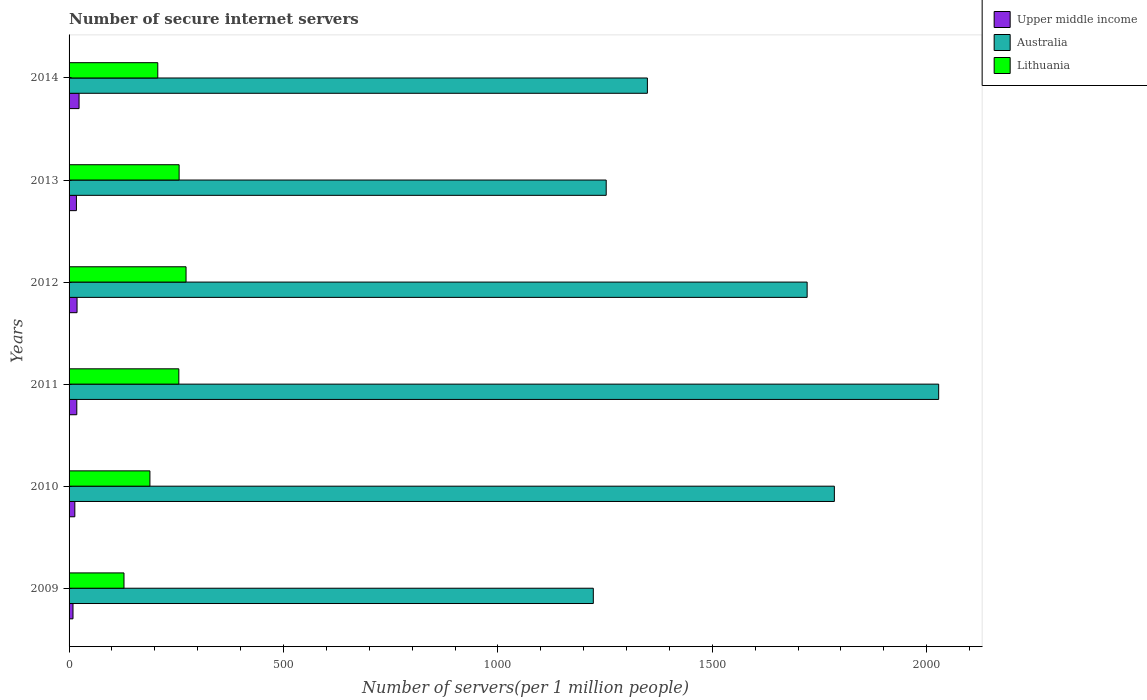How many different coloured bars are there?
Your response must be concise. 3. Are the number of bars per tick equal to the number of legend labels?
Keep it short and to the point. Yes. Are the number of bars on each tick of the Y-axis equal?
Your answer should be compact. Yes. How many bars are there on the 4th tick from the bottom?
Ensure brevity in your answer.  3. What is the number of secure internet servers in Australia in 2011?
Offer a terse response. 2027.8. Across all years, what is the maximum number of secure internet servers in Australia?
Provide a succinct answer. 2027.8. Across all years, what is the minimum number of secure internet servers in Lithuania?
Your response must be concise. 128.05. What is the total number of secure internet servers in Lithuania in the graph?
Make the answer very short. 1308.81. What is the difference between the number of secure internet servers in Lithuania in 2009 and that in 2013?
Your response must be concise. -128.57. What is the difference between the number of secure internet servers in Australia in 2011 and the number of secure internet servers in Lithuania in 2014?
Ensure brevity in your answer.  1820.92. What is the average number of secure internet servers in Upper middle income per year?
Provide a succinct answer. 16.61. In the year 2009, what is the difference between the number of secure internet servers in Upper middle income and number of secure internet servers in Australia?
Give a very brief answer. -1213.29. In how many years, is the number of secure internet servers in Upper middle income greater than 1500 ?
Keep it short and to the point. 0. What is the ratio of the number of secure internet servers in Lithuania in 2010 to that in 2014?
Offer a very short reply. 0.91. Is the number of secure internet servers in Australia in 2009 less than that in 2012?
Keep it short and to the point. Yes. Is the difference between the number of secure internet servers in Upper middle income in 2011 and 2014 greater than the difference between the number of secure internet servers in Australia in 2011 and 2014?
Offer a very short reply. No. What is the difference between the highest and the second highest number of secure internet servers in Lithuania?
Keep it short and to the point. 16.16. What is the difference between the highest and the lowest number of secure internet servers in Australia?
Your response must be concise. 805.35. In how many years, is the number of secure internet servers in Lithuania greater than the average number of secure internet servers in Lithuania taken over all years?
Your answer should be compact. 3. Is the sum of the number of secure internet servers in Upper middle income in 2009 and 2013 greater than the maximum number of secure internet servers in Australia across all years?
Ensure brevity in your answer.  No. What does the 2nd bar from the top in 2013 represents?
Keep it short and to the point. Australia. What does the 3rd bar from the bottom in 2010 represents?
Your answer should be compact. Lithuania. How many bars are there?
Provide a succinct answer. 18. Are the values on the major ticks of X-axis written in scientific E-notation?
Your answer should be very brief. No. Does the graph contain any zero values?
Offer a terse response. No. Does the graph contain grids?
Keep it short and to the point. No. Where does the legend appear in the graph?
Make the answer very short. Top right. How many legend labels are there?
Give a very brief answer. 3. How are the legend labels stacked?
Give a very brief answer. Vertical. What is the title of the graph?
Your answer should be compact. Number of secure internet servers. What is the label or title of the X-axis?
Ensure brevity in your answer.  Number of servers(per 1 million people). What is the Number of servers(per 1 million people) of Upper middle income in 2009?
Make the answer very short. 9.16. What is the Number of servers(per 1 million people) of Australia in 2009?
Give a very brief answer. 1222.45. What is the Number of servers(per 1 million people) of Lithuania in 2009?
Keep it short and to the point. 128.05. What is the Number of servers(per 1 million people) in Upper middle income in 2010?
Keep it short and to the point. 13.42. What is the Number of servers(per 1 million people) in Australia in 2010?
Provide a short and direct response. 1784.56. What is the Number of servers(per 1 million people) of Lithuania in 2010?
Provide a short and direct response. 188.55. What is the Number of servers(per 1 million people) in Upper middle income in 2011?
Keep it short and to the point. 18.02. What is the Number of servers(per 1 million people) in Australia in 2011?
Provide a short and direct response. 2027.8. What is the Number of servers(per 1 million people) of Lithuania in 2011?
Make the answer very short. 255.93. What is the Number of servers(per 1 million people) in Upper middle income in 2012?
Give a very brief answer. 18.6. What is the Number of servers(per 1 million people) of Australia in 2012?
Offer a terse response. 1721.07. What is the Number of servers(per 1 million people) of Lithuania in 2012?
Your response must be concise. 272.78. What is the Number of servers(per 1 million people) in Upper middle income in 2013?
Make the answer very short. 17.16. What is the Number of servers(per 1 million people) in Australia in 2013?
Provide a short and direct response. 1252.54. What is the Number of servers(per 1 million people) in Lithuania in 2013?
Provide a succinct answer. 256.62. What is the Number of servers(per 1 million people) in Upper middle income in 2014?
Make the answer very short. 23.3. What is the Number of servers(per 1 million people) in Australia in 2014?
Make the answer very short. 1348.57. What is the Number of servers(per 1 million people) of Lithuania in 2014?
Provide a succinct answer. 206.87. Across all years, what is the maximum Number of servers(per 1 million people) in Upper middle income?
Your response must be concise. 23.3. Across all years, what is the maximum Number of servers(per 1 million people) in Australia?
Keep it short and to the point. 2027.8. Across all years, what is the maximum Number of servers(per 1 million people) of Lithuania?
Provide a short and direct response. 272.78. Across all years, what is the minimum Number of servers(per 1 million people) of Upper middle income?
Provide a short and direct response. 9.16. Across all years, what is the minimum Number of servers(per 1 million people) in Australia?
Your answer should be compact. 1222.45. Across all years, what is the minimum Number of servers(per 1 million people) of Lithuania?
Provide a short and direct response. 128.05. What is the total Number of servers(per 1 million people) in Upper middle income in the graph?
Provide a succinct answer. 99.66. What is the total Number of servers(per 1 million people) of Australia in the graph?
Your response must be concise. 9356.99. What is the total Number of servers(per 1 million people) of Lithuania in the graph?
Provide a succinct answer. 1308.81. What is the difference between the Number of servers(per 1 million people) of Upper middle income in 2009 and that in 2010?
Offer a very short reply. -4.26. What is the difference between the Number of servers(per 1 million people) of Australia in 2009 and that in 2010?
Ensure brevity in your answer.  -562.11. What is the difference between the Number of servers(per 1 million people) of Lithuania in 2009 and that in 2010?
Make the answer very short. -60.51. What is the difference between the Number of servers(per 1 million people) of Upper middle income in 2009 and that in 2011?
Your response must be concise. -8.86. What is the difference between the Number of servers(per 1 million people) of Australia in 2009 and that in 2011?
Your answer should be compact. -805.35. What is the difference between the Number of servers(per 1 million people) of Lithuania in 2009 and that in 2011?
Provide a succinct answer. -127.89. What is the difference between the Number of servers(per 1 million people) of Upper middle income in 2009 and that in 2012?
Give a very brief answer. -9.43. What is the difference between the Number of servers(per 1 million people) in Australia in 2009 and that in 2012?
Your answer should be very brief. -498.62. What is the difference between the Number of servers(per 1 million people) in Lithuania in 2009 and that in 2012?
Give a very brief answer. -144.73. What is the difference between the Number of servers(per 1 million people) of Upper middle income in 2009 and that in 2013?
Offer a terse response. -7.99. What is the difference between the Number of servers(per 1 million people) of Australia in 2009 and that in 2013?
Give a very brief answer. -30.09. What is the difference between the Number of servers(per 1 million people) of Lithuania in 2009 and that in 2013?
Your answer should be very brief. -128.57. What is the difference between the Number of servers(per 1 million people) of Upper middle income in 2009 and that in 2014?
Your response must be concise. -14.14. What is the difference between the Number of servers(per 1 million people) in Australia in 2009 and that in 2014?
Keep it short and to the point. -126.12. What is the difference between the Number of servers(per 1 million people) of Lithuania in 2009 and that in 2014?
Your answer should be very brief. -78.83. What is the difference between the Number of servers(per 1 million people) of Upper middle income in 2010 and that in 2011?
Keep it short and to the point. -4.6. What is the difference between the Number of servers(per 1 million people) of Australia in 2010 and that in 2011?
Your answer should be very brief. -243.23. What is the difference between the Number of servers(per 1 million people) in Lithuania in 2010 and that in 2011?
Provide a succinct answer. -67.38. What is the difference between the Number of servers(per 1 million people) in Upper middle income in 2010 and that in 2012?
Provide a succinct answer. -5.17. What is the difference between the Number of servers(per 1 million people) of Australia in 2010 and that in 2012?
Your answer should be compact. 63.49. What is the difference between the Number of servers(per 1 million people) of Lithuania in 2010 and that in 2012?
Provide a succinct answer. -84.23. What is the difference between the Number of servers(per 1 million people) in Upper middle income in 2010 and that in 2013?
Offer a terse response. -3.73. What is the difference between the Number of servers(per 1 million people) of Australia in 2010 and that in 2013?
Offer a terse response. 532.02. What is the difference between the Number of servers(per 1 million people) of Lithuania in 2010 and that in 2013?
Offer a terse response. -68.07. What is the difference between the Number of servers(per 1 million people) of Upper middle income in 2010 and that in 2014?
Your answer should be compact. -9.88. What is the difference between the Number of servers(per 1 million people) in Australia in 2010 and that in 2014?
Make the answer very short. 435.99. What is the difference between the Number of servers(per 1 million people) of Lithuania in 2010 and that in 2014?
Offer a terse response. -18.32. What is the difference between the Number of servers(per 1 million people) in Upper middle income in 2011 and that in 2012?
Make the answer very short. -0.58. What is the difference between the Number of servers(per 1 million people) of Australia in 2011 and that in 2012?
Make the answer very short. 306.72. What is the difference between the Number of servers(per 1 million people) of Lithuania in 2011 and that in 2012?
Provide a short and direct response. -16.84. What is the difference between the Number of servers(per 1 million people) of Upper middle income in 2011 and that in 2013?
Your answer should be compact. 0.86. What is the difference between the Number of servers(per 1 million people) of Australia in 2011 and that in 2013?
Your response must be concise. 775.26. What is the difference between the Number of servers(per 1 million people) in Lithuania in 2011 and that in 2013?
Provide a short and direct response. -0.68. What is the difference between the Number of servers(per 1 million people) in Upper middle income in 2011 and that in 2014?
Ensure brevity in your answer.  -5.28. What is the difference between the Number of servers(per 1 million people) in Australia in 2011 and that in 2014?
Provide a short and direct response. 679.22. What is the difference between the Number of servers(per 1 million people) of Lithuania in 2011 and that in 2014?
Offer a very short reply. 49.06. What is the difference between the Number of servers(per 1 million people) of Upper middle income in 2012 and that in 2013?
Ensure brevity in your answer.  1.44. What is the difference between the Number of servers(per 1 million people) of Australia in 2012 and that in 2013?
Keep it short and to the point. 468.54. What is the difference between the Number of servers(per 1 million people) of Lithuania in 2012 and that in 2013?
Your answer should be very brief. 16.16. What is the difference between the Number of servers(per 1 million people) of Upper middle income in 2012 and that in 2014?
Provide a succinct answer. -4.7. What is the difference between the Number of servers(per 1 million people) in Australia in 2012 and that in 2014?
Make the answer very short. 372.5. What is the difference between the Number of servers(per 1 million people) in Lithuania in 2012 and that in 2014?
Offer a very short reply. 65.9. What is the difference between the Number of servers(per 1 million people) in Upper middle income in 2013 and that in 2014?
Ensure brevity in your answer.  -6.14. What is the difference between the Number of servers(per 1 million people) of Australia in 2013 and that in 2014?
Give a very brief answer. -96.04. What is the difference between the Number of servers(per 1 million people) of Lithuania in 2013 and that in 2014?
Ensure brevity in your answer.  49.75. What is the difference between the Number of servers(per 1 million people) in Upper middle income in 2009 and the Number of servers(per 1 million people) in Australia in 2010?
Offer a very short reply. -1775.4. What is the difference between the Number of servers(per 1 million people) of Upper middle income in 2009 and the Number of servers(per 1 million people) of Lithuania in 2010?
Your response must be concise. -179.39. What is the difference between the Number of servers(per 1 million people) of Australia in 2009 and the Number of servers(per 1 million people) of Lithuania in 2010?
Your answer should be compact. 1033.9. What is the difference between the Number of servers(per 1 million people) in Upper middle income in 2009 and the Number of servers(per 1 million people) in Australia in 2011?
Offer a very short reply. -2018.63. What is the difference between the Number of servers(per 1 million people) of Upper middle income in 2009 and the Number of servers(per 1 million people) of Lithuania in 2011?
Keep it short and to the point. -246.77. What is the difference between the Number of servers(per 1 million people) in Australia in 2009 and the Number of servers(per 1 million people) in Lithuania in 2011?
Make the answer very short. 966.51. What is the difference between the Number of servers(per 1 million people) in Upper middle income in 2009 and the Number of servers(per 1 million people) in Australia in 2012?
Make the answer very short. -1711.91. What is the difference between the Number of servers(per 1 million people) of Upper middle income in 2009 and the Number of servers(per 1 million people) of Lithuania in 2012?
Give a very brief answer. -263.62. What is the difference between the Number of servers(per 1 million people) of Australia in 2009 and the Number of servers(per 1 million people) of Lithuania in 2012?
Your response must be concise. 949.67. What is the difference between the Number of servers(per 1 million people) in Upper middle income in 2009 and the Number of servers(per 1 million people) in Australia in 2013?
Ensure brevity in your answer.  -1243.37. What is the difference between the Number of servers(per 1 million people) of Upper middle income in 2009 and the Number of servers(per 1 million people) of Lithuania in 2013?
Make the answer very short. -247.46. What is the difference between the Number of servers(per 1 million people) of Australia in 2009 and the Number of servers(per 1 million people) of Lithuania in 2013?
Make the answer very short. 965.83. What is the difference between the Number of servers(per 1 million people) of Upper middle income in 2009 and the Number of servers(per 1 million people) of Australia in 2014?
Provide a short and direct response. -1339.41. What is the difference between the Number of servers(per 1 million people) of Upper middle income in 2009 and the Number of servers(per 1 million people) of Lithuania in 2014?
Offer a very short reply. -197.71. What is the difference between the Number of servers(per 1 million people) in Australia in 2009 and the Number of servers(per 1 million people) in Lithuania in 2014?
Provide a short and direct response. 1015.58. What is the difference between the Number of servers(per 1 million people) of Upper middle income in 2010 and the Number of servers(per 1 million people) of Australia in 2011?
Offer a terse response. -2014.37. What is the difference between the Number of servers(per 1 million people) in Upper middle income in 2010 and the Number of servers(per 1 million people) in Lithuania in 2011?
Ensure brevity in your answer.  -242.51. What is the difference between the Number of servers(per 1 million people) of Australia in 2010 and the Number of servers(per 1 million people) of Lithuania in 2011?
Keep it short and to the point. 1528.63. What is the difference between the Number of servers(per 1 million people) in Upper middle income in 2010 and the Number of servers(per 1 million people) in Australia in 2012?
Your response must be concise. -1707.65. What is the difference between the Number of servers(per 1 million people) in Upper middle income in 2010 and the Number of servers(per 1 million people) in Lithuania in 2012?
Your answer should be very brief. -259.35. What is the difference between the Number of servers(per 1 million people) of Australia in 2010 and the Number of servers(per 1 million people) of Lithuania in 2012?
Your response must be concise. 1511.78. What is the difference between the Number of servers(per 1 million people) of Upper middle income in 2010 and the Number of servers(per 1 million people) of Australia in 2013?
Keep it short and to the point. -1239.11. What is the difference between the Number of servers(per 1 million people) in Upper middle income in 2010 and the Number of servers(per 1 million people) in Lithuania in 2013?
Provide a succinct answer. -243.2. What is the difference between the Number of servers(per 1 million people) of Australia in 2010 and the Number of servers(per 1 million people) of Lithuania in 2013?
Provide a short and direct response. 1527.94. What is the difference between the Number of servers(per 1 million people) in Upper middle income in 2010 and the Number of servers(per 1 million people) in Australia in 2014?
Provide a succinct answer. -1335.15. What is the difference between the Number of servers(per 1 million people) of Upper middle income in 2010 and the Number of servers(per 1 million people) of Lithuania in 2014?
Give a very brief answer. -193.45. What is the difference between the Number of servers(per 1 million people) of Australia in 2010 and the Number of servers(per 1 million people) of Lithuania in 2014?
Provide a succinct answer. 1577.69. What is the difference between the Number of servers(per 1 million people) of Upper middle income in 2011 and the Number of servers(per 1 million people) of Australia in 2012?
Your response must be concise. -1703.05. What is the difference between the Number of servers(per 1 million people) in Upper middle income in 2011 and the Number of servers(per 1 million people) in Lithuania in 2012?
Your answer should be very brief. -254.76. What is the difference between the Number of servers(per 1 million people) in Australia in 2011 and the Number of servers(per 1 million people) in Lithuania in 2012?
Your answer should be compact. 1755.02. What is the difference between the Number of servers(per 1 million people) in Upper middle income in 2011 and the Number of servers(per 1 million people) in Australia in 2013?
Your answer should be very brief. -1234.52. What is the difference between the Number of servers(per 1 million people) in Upper middle income in 2011 and the Number of servers(per 1 million people) in Lithuania in 2013?
Keep it short and to the point. -238.6. What is the difference between the Number of servers(per 1 million people) of Australia in 2011 and the Number of servers(per 1 million people) of Lithuania in 2013?
Your answer should be very brief. 1771.18. What is the difference between the Number of servers(per 1 million people) of Upper middle income in 2011 and the Number of servers(per 1 million people) of Australia in 2014?
Keep it short and to the point. -1330.55. What is the difference between the Number of servers(per 1 million people) of Upper middle income in 2011 and the Number of servers(per 1 million people) of Lithuania in 2014?
Provide a succinct answer. -188.85. What is the difference between the Number of servers(per 1 million people) of Australia in 2011 and the Number of servers(per 1 million people) of Lithuania in 2014?
Offer a terse response. 1820.92. What is the difference between the Number of servers(per 1 million people) of Upper middle income in 2012 and the Number of servers(per 1 million people) of Australia in 2013?
Offer a terse response. -1233.94. What is the difference between the Number of servers(per 1 million people) in Upper middle income in 2012 and the Number of servers(per 1 million people) in Lithuania in 2013?
Your response must be concise. -238.02. What is the difference between the Number of servers(per 1 million people) in Australia in 2012 and the Number of servers(per 1 million people) in Lithuania in 2013?
Give a very brief answer. 1464.45. What is the difference between the Number of servers(per 1 million people) of Upper middle income in 2012 and the Number of servers(per 1 million people) of Australia in 2014?
Provide a short and direct response. -1329.98. What is the difference between the Number of servers(per 1 million people) of Upper middle income in 2012 and the Number of servers(per 1 million people) of Lithuania in 2014?
Your response must be concise. -188.28. What is the difference between the Number of servers(per 1 million people) of Australia in 2012 and the Number of servers(per 1 million people) of Lithuania in 2014?
Make the answer very short. 1514.2. What is the difference between the Number of servers(per 1 million people) in Upper middle income in 2013 and the Number of servers(per 1 million people) in Australia in 2014?
Your answer should be very brief. -1331.42. What is the difference between the Number of servers(per 1 million people) in Upper middle income in 2013 and the Number of servers(per 1 million people) in Lithuania in 2014?
Provide a short and direct response. -189.72. What is the difference between the Number of servers(per 1 million people) in Australia in 2013 and the Number of servers(per 1 million people) in Lithuania in 2014?
Your response must be concise. 1045.66. What is the average Number of servers(per 1 million people) in Upper middle income per year?
Keep it short and to the point. 16.61. What is the average Number of servers(per 1 million people) in Australia per year?
Provide a succinct answer. 1559.5. What is the average Number of servers(per 1 million people) in Lithuania per year?
Give a very brief answer. 218.13. In the year 2009, what is the difference between the Number of servers(per 1 million people) in Upper middle income and Number of servers(per 1 million people) in Australia?
Make the answer very short. -1213.29. In the year 2009, what is the difference between the Number of servers(per 1 million people) in Upper middle income and Number of servers(per 1 million people) in Lithuania?
Make the answer very short. -118.88. In the year 2009, what is the difference between the Number of servers(per 1 million people) in Australia and Number of servers(per 1 million people) in Lithuania?
Keep it short and to the point. 1094.4. In the year 2010, what is the difference between the Number of servers(per 1 million people) in Upper middle income and Number of servers(per 1 million people) in Australia?
Ensure brevity in your answer.  -1771.14. In the year 2010, what is the difference between the Number of servers(per 1 million people) of Upper middle income and Number of servers(per 1 million people) of Lithuania?
Give a very brief answer. -175.13. In the year 2010, what is the difference between the Number of servers(per 1 million people) in Australia and Number of servers(per 1 million people) in Lithuania?
Ensure brevity in your answer.  1596.01. In the year 2011, what is the difference between the Number of servers(per 1 million people) in Upper middle income and Number of servers(per 1 million people) in Australia?
Provide a short and direct response. -2009.77. In the year 2011, what is the difference between the Number of servers(per 1 million people) in Upper middle income and Number of servers(per 1 million people) in Lithuania?
Provide a short and direct response. -237.91. In the year 2011, what is the difference between the Number of servers(per 1 million people) of Australia and Number of servers(per 1 million people) of Lithuania?
Offer a very short reply. 1771.86. In the year 2012, what is the difference between the Number of servers(per 1 million people) of Upper middle income and Number of servers(per 1 million people) of Australia?
Offer a very short reply. -1702.48. In the year 2012, what is the difference between the Number of servers(per 1 million people) in Upper middle income and Number of servers(per 1 million people) in Lithuania?
Keep it short and to the point. -254.18. In the year 2012, what is the difference between the Number of servers(per 1 million people) of Australia and Number of servers(per 1 million people) of Lithuania?
Provide a short and direct response. 1448.3. In the year 2013, what is the difference between the Number of servers(per 1 million people) of Upper middle income and Number of servers(per 1 million people) of Australia?
Keep it short and to the point. -1235.38. In the year 2013, what is the difference between the Number of servers(per 1 million people) of Upper middle income and Number of servers(per 1 million people) of Lithuania?
Ensure brevity in your answer.  -239.46. In the year 2013, what is the difference between the Number of servers(per 1 million people) in Australia and Number of servers(per 1 million people) in Lithuania?
Keep it short and to the point. 995.92. In the year 2014, what is the difference between the Number of servers(per 1 million people) of Upper middle income and Number of servers(per 1 million people) of Australia?
Your response must be concise. -1325.27. In the year 2014, what is the difference between the Number of servers(per 1 million people) in Upper middle income and Number of servers(per 1 million people) in Lithuania?
Your answer should be very brief. -183.57. In the year 2014, what is the difference between the Number of servers(per 1 million people) in Australia and Number of servers(per 1 million people) in Lithuania?
Give a very brief answer. 1141.7. What is the ratio of the Number of servers(per 1 million people) in Upper middle income in 2009 to that in 2010?
Provide a succinct answer. 0.68. What is the ratio of the Number of servers(per 1 million people) in Australia in 2009 to that in 2010?
Give a very brief answer. 0.69. What is the ratio of the Number of servers(per 1 million people) of Lithuania in 2009 to that in 2010?
Offer a terse response. 0.68. What is the ratio of the Number of servers(per 1 million people) in Upper middle income in 2009 to that in 2011?
Your answer should be compact. 0.51. What is the ratio of the Number of servers(per 1 million people) of Australia in 2009 to that in 2011?
Give a very brief answer. 0.6. What is the ratio of the Number of servers(per 1 million people) of Lithuania in 2009 to that in 2011?
Provide a succinct answer. 0.5. What is the ratio of the Number of servers(per 1 million people) of Upper middle income in 2009 to that in 2012?
Offer a very short reply. 0.49. What is the ratio of the Number of servers(per 1 million people) in Australia in 2009 to that in 2012?
Ensure brevity in your answer.  0.71. What is the ratio of the Number of servers(per 1 million people) in Lithuania in 2009 to that in 2012?
Your answer should be compact. 0.47. What is the ratio of the Number of servers(per 1 million people) of Upper middle income in 2009 to that in 2013?
Ensure brevity in your answer.  0.53. What is the ratio of the Number of servers(per 1 million people) in Lithuania in 2009 to that in 2013?
Your answer should be compact. 0.5. What is the ratio of the Number of servers(per 1 million people) in Upper middle income in 2009 to that in 2014?
Ensure brevity in your answer.  0.39. What is the ratio of the Number of servers(per 1 million people) in Australia in 2009 to that in 2014?
Your response must be concise. 0.91. What is the ratio of the Number of servers(per 1 million people) of Lithuania in 2009 to that in 2014?
Keep it short and to the point. 0.62. What is the ratio of the Number of servers(per 1 million people) of Upper middle income in 2010 to that in 2011?
Make the answer very short. 0.74. What is the ratio of the Number of servers(per 1 million people) of Australia in 2010 to that in 2011?
Your response must be concise. 0.88. What is the ratio of the Number of servers(per 1 million people) in Lithuania in 2010 to that in 2011?
Your answer should be compact. 0.74. What is the ratio of the Number of servers(per 1 million people) in Upper middle income in 2010 to that in 2012?
Keep it short and to the point. 0.72. What is the ratio of the Number of servers(per 1 million people) of Australia in 2010 to that in 2012?
Your answer should be very brief. 1.04. What is the ratio of the Number of servers(per 1 million people) of Lithuania in 2010 to that in 2012?
Make the answer very short. 0.69. What is the ratio of the Number of servers(per 1 million people) of Upper middle income in 2010 to that in 2013?
Make the answer very short. 0.78. What is the ratio of the Number of servers(per 1 million people) in Australia in 2010 to that in 2013?
Give a very brief answer. 1.42. What is the ratio of the Number of servers(per 1 million people) in Lithuania in 2010 to that in 2013?
Ensure brevity in your answer.  0.73. What is the ratio of the Number of servers(per 1 million people) of Upper middle income in 2010 to that in 2014?
Make the answer very short. 0.58. What is the ratio of the Number of servers(per 1 million people) in Australia in 2010 to that in 2014?
Give a very brief answer. 1.32. What is the ratio of the Number of servers(per 1 million people) of Lithuania in 2010 to that in 2014?
Your answer should be compact. 0.91. What is the ratio of the Number of servers(per 1 million people) in Australia in 2011 to that in 2012?
Your answer should be very brief. 1.18. What is the ratio of the Number of servers(per 1 million people) in Lithuania in 2011 to that in 2012?
Make the answer very short. 0.94. What is the ratio of the Number of servers(per 1 million people) in Upper middle income in 2011 to that in 2013?
Provide a succinct answer. 1.05. What is the ratio of the Number of servers(per 1 million people) of Australia in 2011 to that in 2013?
Make the answer very short. 1.62. What is the ratio of the Number of servers(per 1 million people) of Lithuania in 2011 to that in 2013?
Your answer should be very brief. 1. What is the ratio of the Number of servers(per 1 million people) of Upper middle income in 2011 to that in 2014?
Offer a very short reply. 0.77. What is the ratio of the Number of servers(per 1 million people) in Australia in 2011 to that in 2014?
Keep it short and to the point. 1.5. What is the ratio of the Number of servers(per 1 million people) in Lithuania in 2011 to that in 2014?
Your response must be concise. 1.24. What is the ratio of the Number of servers(per 1 million people) in Upper middle income in 2012 to that in 2013?
Give a very brief answer. 1.08. What is the ratio of the Number of servers(per 1 million people) in Australia in 2012 to that in 2013?
Your answer should be very brief. 1.37. What is the ratio of the Number of servers(per 1 million people) in Lithuania in 2012 to that in 2013?
Offer a terse response. 1.06. What is the ratio of the Number of servers(per 1 million people) in Upper middle income in 2012 to that in 2014?
Make the answer very short. 0.8. What is the ratio of the Number of servers(per 1 million people) in Australia in 2012 to that in 2014?
Make the answer very short. 1.28. What is the ratio of the Number of servers(per 1 million people) in Lithuania in 2012 to that in 2014?
Provide a succinct answer. 1.32. What is the ratio of the Number of servers(per 1 million people) of Upper middle income in 2013 to that in 2014?
Offer a terse response. 0.74. What is the ratio of the Number of servers(per 1 million people) of Australia in 2013 to that in 2014?
Offer a terse response. 0.93. What is the ratio of the Number of servers(per 1 million people) in Lithuania in 2013 to that in 2014?
Provide a short and direct response. 1.24. What is the difference between the highest and the second highest Number of servers(per 1 million people) in Upper middle income?
Offer a terse response. 4.7. What is the difference between the highest and the second highest Number of servers(per 1 million people) of Australia?
Provide a short and direct response. 243.23. What is the difference between the highest and the second highest Number of servers(per 1 million people) of Lithuania?
Provide a short and direct response. 16.16. What is the difference between the highest and the lowest Number of servers(per 1 million people) of Upper middle income?
Offer a very short reply. 14.14. What is the difference between the highest and the lowest Number of servers(per 1 million people) of Australia?
Keep it short and to the point. 805.35. What is the difference between the highest and the lowest Number of servers(per 1 million people) in Lithuania?
Ensure brevity in your answer.  144.73. 